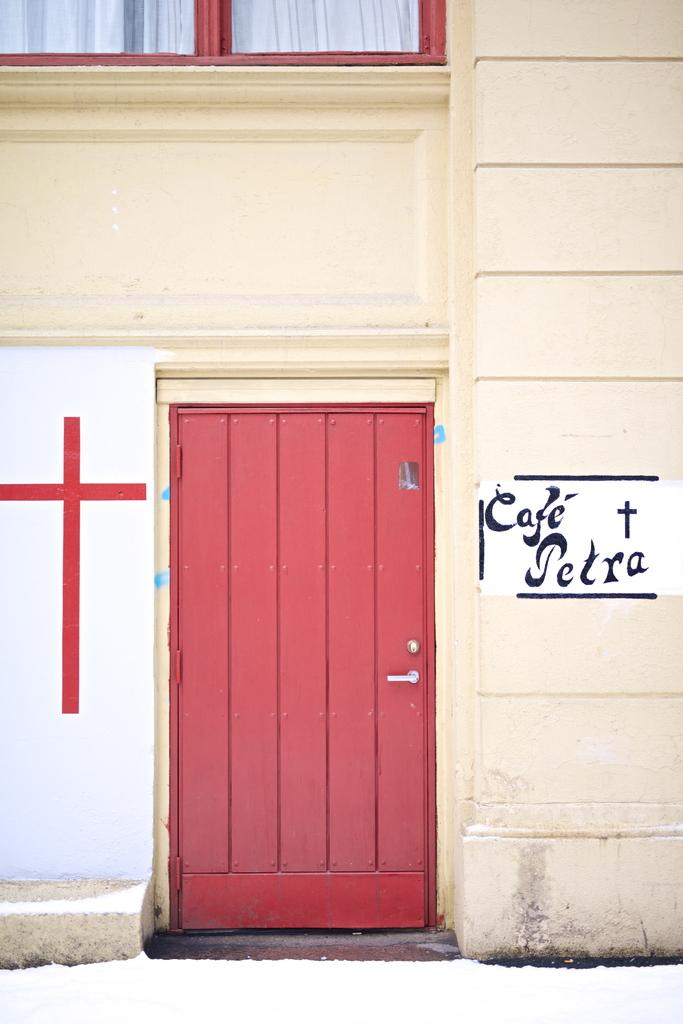What can be found on the wall on the left side of the image? There is a painting on the wall on the left side of the image. What is located on the right side of the image? There is text on the wall on the right side of the image. What is the main architectural feature in the image? There is a door in the image. Can you see a monkey coiling a point in the image? There is no monkey or coiling point present in the image. 